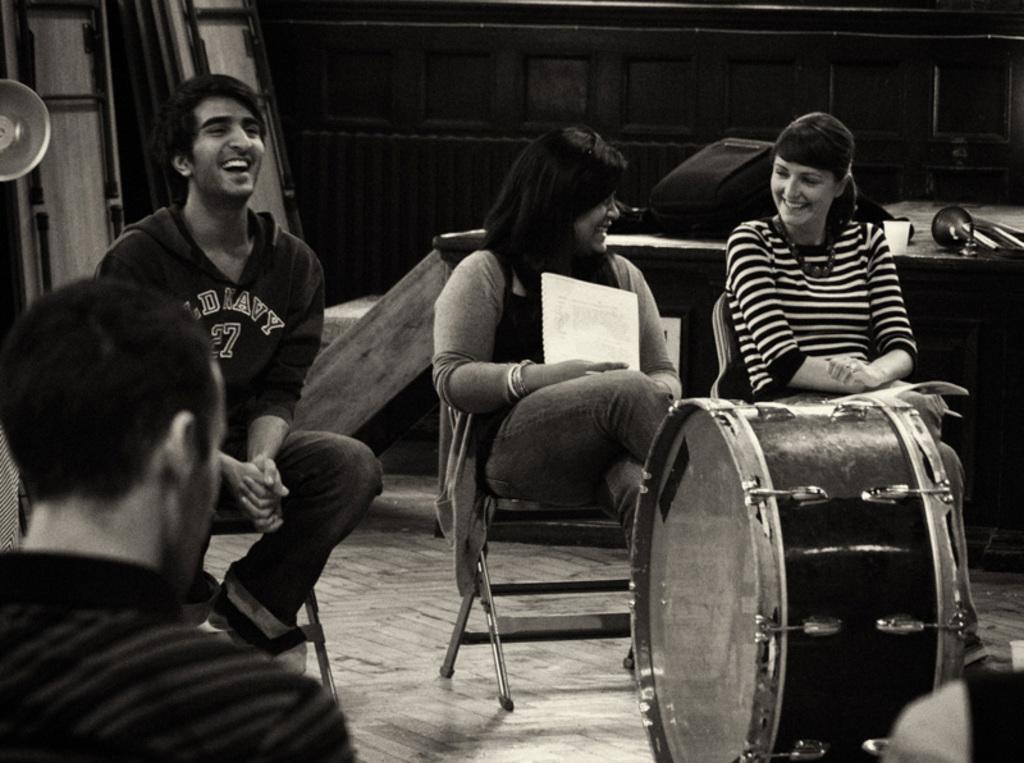How many people are sitting in chairs in the image? There are three people sitting in chairs in the image. What is the facial expression of the people in the image? The three people are smiling. What object is in front of the people? There is a drum in front of the people. Is there anyone else present in the image besides the three people sitting in chairs? Yes, there is another person sitting in the left corner of the image. What type of yard can be seen in the background of the image? There is no yard visible in the image; it features a drum and people sitting in chairs. 